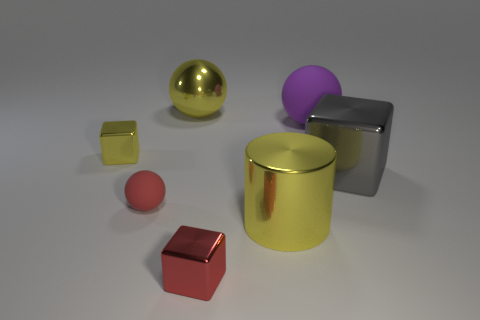There is a yellow block that is the same size as the red sphere; what material is it?
Keep it short and to the point. Metal. Is there a yellow shiny cylinder that has the same size as the red rubber sphere?
Make the answer very short. No. What number of tiny red metallic blocks are there?
Provide a succinct answer. 1. What number of small red things are to the right of the red rubber thing?
Provide a succinct answer. 1. Is the gray cube made of the same material as the big purple object?
Keep it short and to the point. No. What number of rubber spheres are both left of the big rubber sphere and to the right of the large yellow ball?
Ensure brevity in your answer.  0. How many other things are there of the same color as the big cube?
Make the answer very short. 0. How many cyan things are either rubber things or balls?
Provide a succinct answer. 0. What size is the red cube?
Keep it short and to the point. Small. What number of rubber objects are green objects or big gray things?
Make the answer very short. 0. 